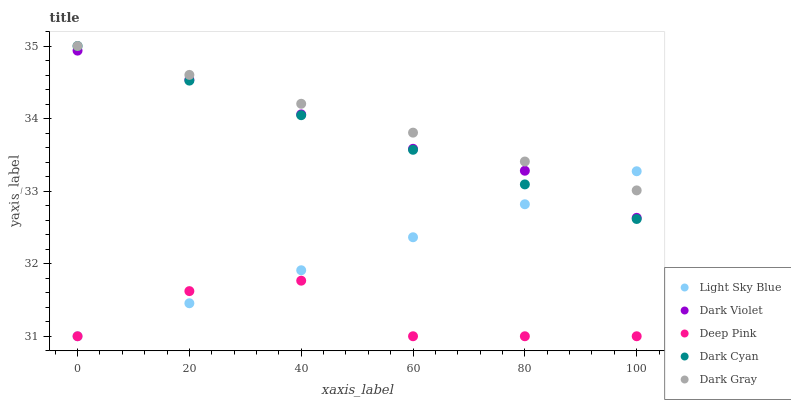Does Deep Pink have the minimum area under the curve?
Answer yes or no. Yes. Does Dark Gray have the maximum area under the curve?
Answer yes or no. Yes. Does Light Sky Blue have the minimum area under the curve?
Answer yes or no. No. Does Light Sky Blue have the maximum area under the curve?
Answer yes or no. No. Is Light Sky Blue the smoothest?
Answer yes or no. Yes. Is Deep Pink the roughest?
Answer yes or no. Yes. Is Dark Gray the smoothest?
Answer yes or no. No. Is Dark Gray the roughest?
Answer yes or no. No. Does Light Sky Blue have the lowest value?
Answer yes or no. Yes. Does Dark Gray have the lowest value?
Answer yes or no. No. Does Dark Gray have the highest value?
Answer yes or no. Yes. Does Light Sky Blue have the highest value?
Answer yes or no. No. Is Deep Pink less than Dark Gray?
Answer yes or no. Yes. Is Dark Violet greater than Deep Pink?
Answer yes or no. Yes. Does Dark Gray intersect Light Sky Blue?
Answer yes or no. Yes. Is Dark Gray less than Light Sky Blue?
Answer yes or no. No. Is Dark Gray greater than Light Sky Blue?
Answer yes or no. No. Does Deep Pink intersect Dark Gray?
Answer yes or no. No. 